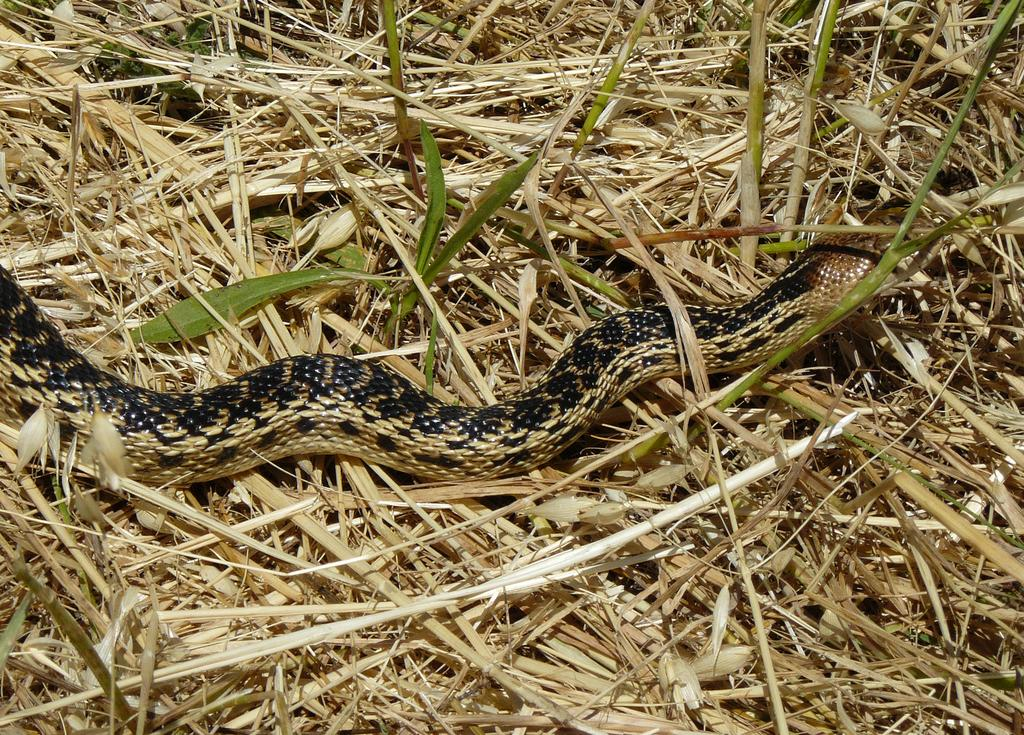What animal is present in the image? There is a snake in the image. What is the snake resting on? The snake is on grass. Can you describe the possible setting of the image? The image may have been taken in a farm. How many grapes are hanging from the snake in the image? There are no grapes present in the image, and the snake is not holding or interacting with any grapes. 